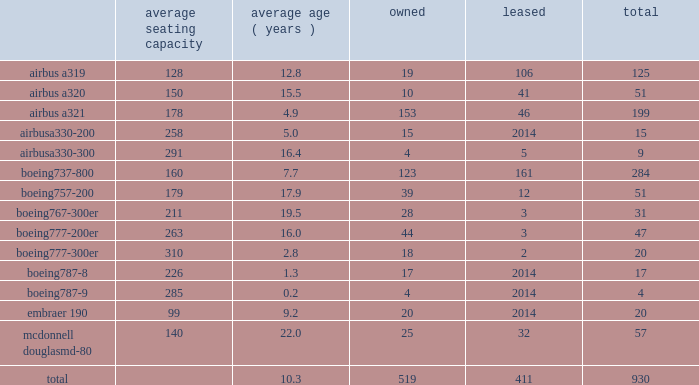Table of contents item 2 .
Properties flight equipment and fleet renewal as of december 31 , 2016 , american operated a mainline fleet of 930 aircraft .
In 2016 , we continued our extensive fleet renewal program , which has provided us with the youngest fleet of the major u.s .
Network carriers .
During 2016 , american took delivery of 55 new mainline aircraft and retired 71 aircraft .
We are supported by our wholly-owned and third-party regional carriers that fly under capacity purchase agreements operating as american eagle .
As of december 31 , 2016 , american eagle operated 606 regional aircraft .
During 2016 , we increased our regional fleet by 61 regional aircraft , we removed and placed in temporary storage one embraer erj 140 aircraft and retired 41 other regional aircraft .
Mainline as of december 31 , 2016 , american 2019s mainline fleet consisted of the following aircraft : average seating capacity average ( years ) owned leased total .

What is the average passenger capacity for the airbus planes in american's fleet? 
Computations: (((((128 + 150) + 178) + 258) + 291) / 5)
Answer: 201.0. 